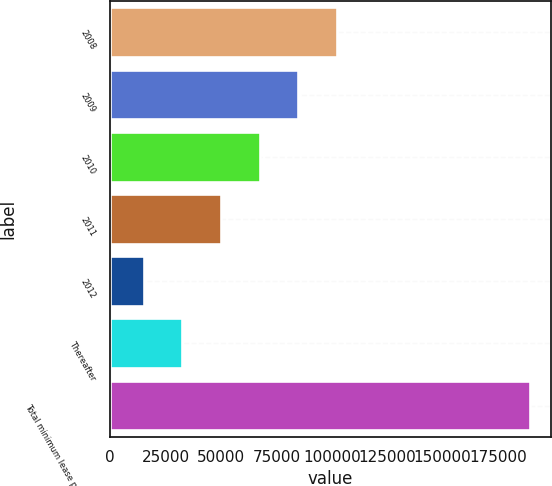Convert chart to OTSL. <chart><loc_0><loc_0><loc_500><loc_500><bar_chart><fcel>2008<fcel>2009<fcel>2010<fcel>2011<fcel>2012<fcel>Thereafter<fcel>Total minimum lease payments<nl><fcel>102314<fcel>84881.2<fcel>67448.4<fcel>50015.6<fcel>15150<fcel>32582.8<fcel>189478<nl></chart> 